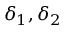<formula> <loc_0><loc_0><loc_500><loc_500>\delta _ { 1 } , \delta _ { 2 }</formula> 